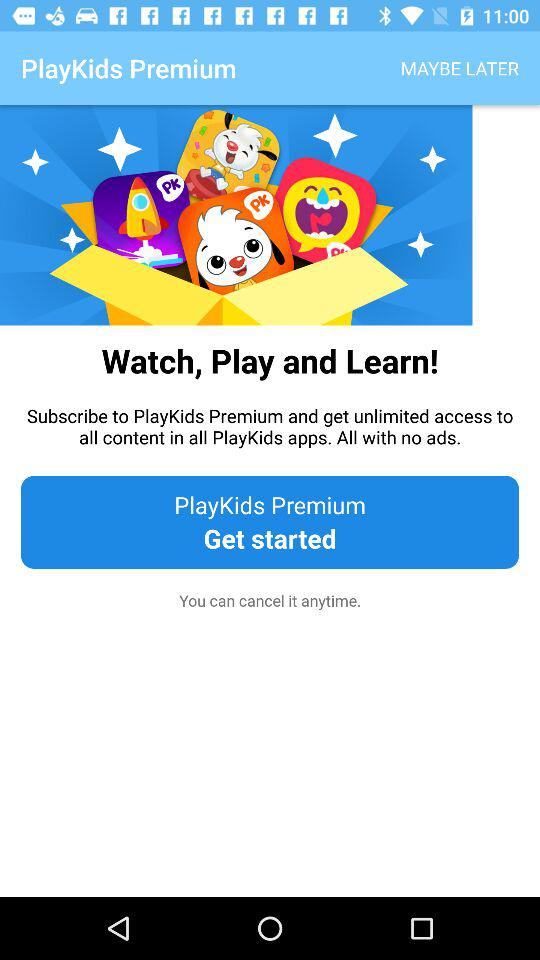What are the benefits of the "PlayKids" premium subscription? The benefits are unlimited access to all content in all "PlayKids" apps and all with no ads. 